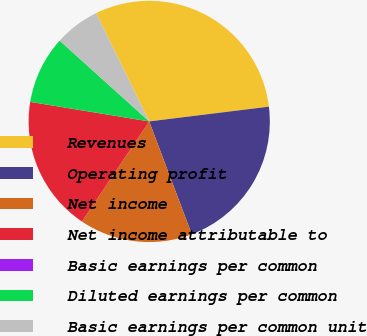Convert chart to OTSL. <chart><loc_0><loc_0><loc_500><loc_500><pie_chart><fcel>Revenues<fcel>Operating profit<fcel>Net income<fcel>Net income attributable to<fcel>Basic earnings per common<fcel>Diluted earnings per common<fcel>Basic earnings per common unit<nl><fcel>30.3%<fcel>21.21%<fcel>15.15%<fcel>18.18%<fcel>0.0%<fcel>9.09%<fcel>6.06%<nl></chart> 